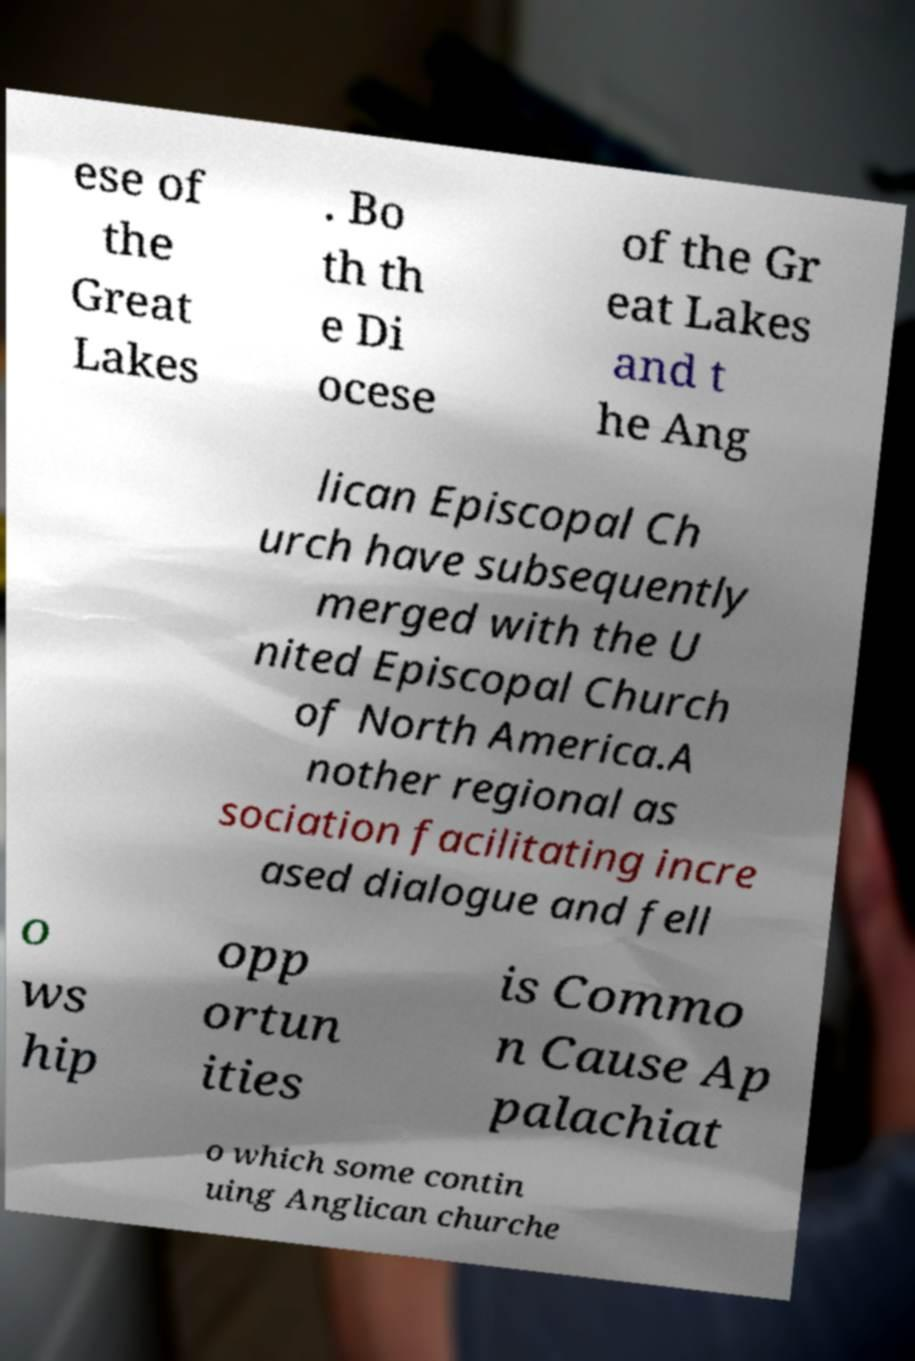Could you assist in decoding the text presented in this image and type it out clearly? ese of the Great Lakes . Bo th th e Di ocese of the Gr eat Lakes and t he Ang lican Episcopal Ch urch have subsequently merged with the U nited Episcopal Church of North America.A nother regional as sociation facilitating incre ased dialogue and fell o ws hip opp ortun ities is Commo n Cause Ap palachiat o which some contin uing Anglican churche 